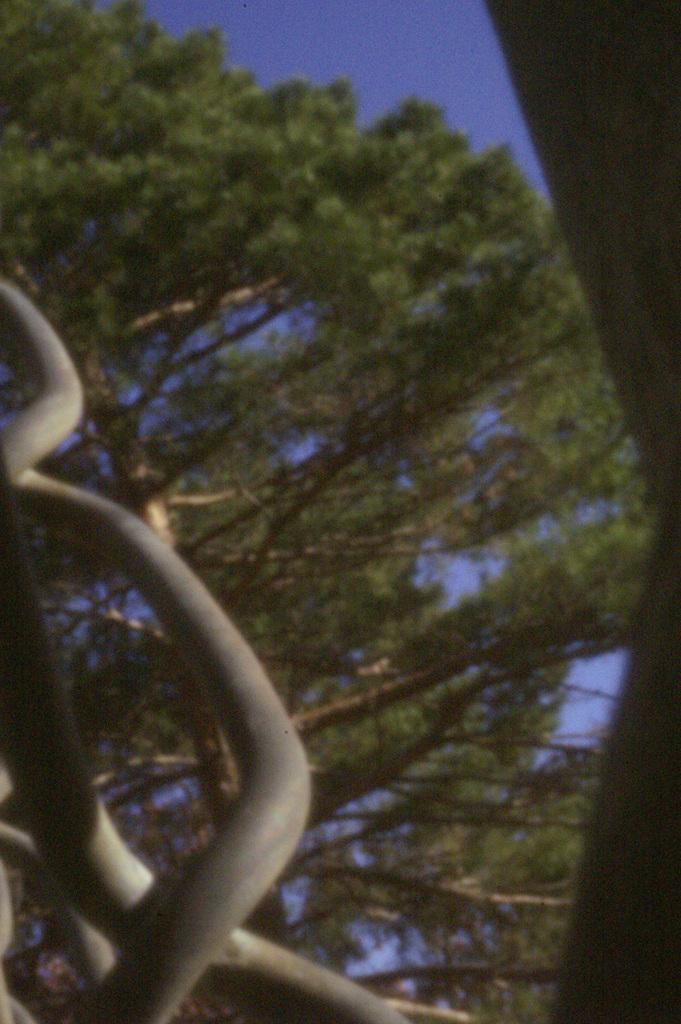What type of vegetation is visible in the image? There are trees in the image. What else can be seen in the image besides the trees? There are objects visible in the image. What color is the sky in the image? The sky is blue in the image. What is the income of the trees in the image? Trees do not have an income, as they are living organisms and not people or businesses. Can you see a sail in the image? There is no sail present in the image. 